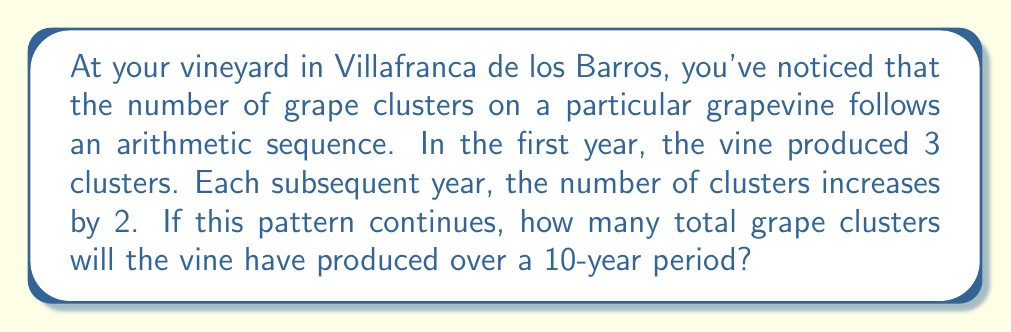Teach me how to tackle this problem. Let's approach this step-by-step using arithmetic sequences and series:

1) First, we need to identify the components of our arithmetic sequence:
   - $a_1 = 3$ (first term, representing the number of clusters in the first year)
   - $d = 2$ (common difference, the increase each year)
   - $n = 10$ (number of terms, representing 10 years)

2) The arithmetic sequence for the number of clusters each year would be:
   $3, 5, 7, 9, 11, 13, 15, 17, 19, 21$

3) To find the total number of clusters over 10 years, we need to sum this sequence. We can use the formula for the sum of an arithmetic series:

   $S_n = \frac{n}{2}(a_1 + a_n)$

   Where $S_n$ is the sum of the series, $n$ is the number of terms, $a_1$ is the first term, and $a_n$ is the last term.

4) We know $a_1 = 3$ and $n = 10$, but we need to calculate $a_n$:
   $a_n = a_1 + (n-1)d = 3 + (10-1)2 = 3 + 18 = 21$

5) Now we can plug these values into our sum formula:

   $S_{10} = \frac{10}{2}(3 + 21) = 5(24) = 120$

Therefore, over a 10-year period, the grapevine will have produced a total of 120 clusters.
Answer: 120 grape clusters 